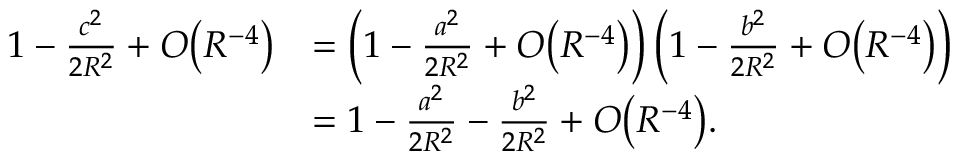Convert formula to latex. <formula><loc_0><loc_0><loc_500><loc_500>{ \begin{array} { r l } { 1 - { \frac { c ^ { 2 } } { 2 R ^ { 2 } } } + O { \left ( R ^ { - 4 } \right ) } } & { = \left ( 1 - { \frac { a ^ { 2 } } { 2 R ^ { 2 } } } + O { \left ( R ^ { - 4 } \right ) } \right ) \left ( 1 - { \frac { b ^ { 2 } } { 2 R ^ { 2 } } } + O { \left ( R ^ { - 4 } \right ) } \right ) } \\ & { = 1 - { \frac { a ^ { 2 } } { 2 R ^ { 2 } } } - { \frac { b ^ { 2 } } { 2 R ^ { 2 } } } + O { \left ( R ^ { - 4 } \right ) } . } \end{array} }</formula> 